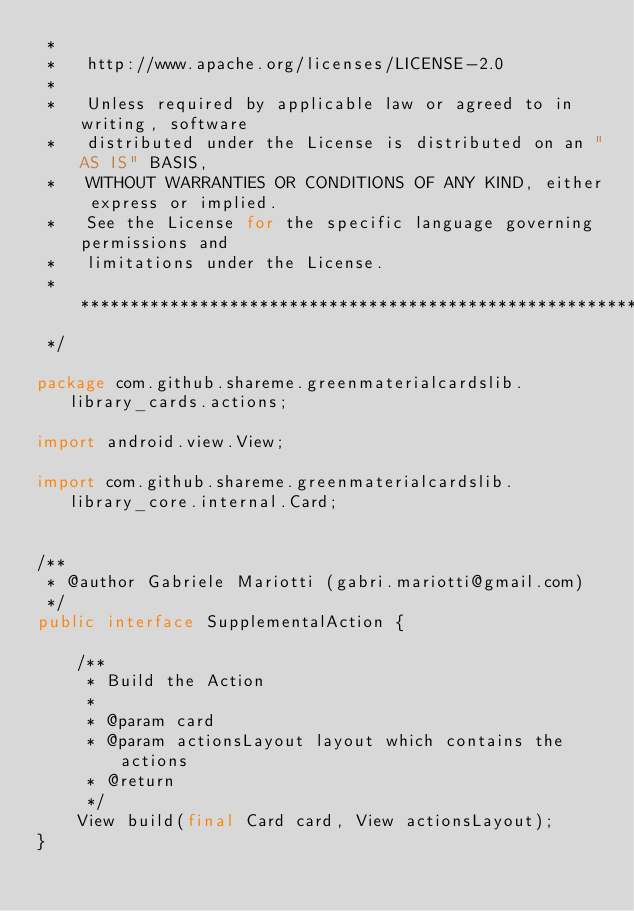Convert code to text. <code><loc_0><loc_0><loc_500><loc_500><_Java_> *
 *   http://www.apache.org/licenses/LICENSE-2.0
 *
 *   Unless required by applicable law or agreed to in writing, software
 *   distributed under the License is distributed on an "AS IS" BASIS,
 *   WITHOUT WARRANTIES OR CONDITIONS OF ANY KIND, either express or implied.
 *   See the License for the specific language governing permissions and
 *   limitations under the License.
 *  *****************************************************************************
 */

package com.github.shareme.greenmaterialcardslib.library_cards.actions;

import android.view.View;

import com.github.shareme.greenmaterialcardslib.library_core.internal.Card;


/**
 * @author Gabriele Mariotti (gabri.mariotti@gmail.com)
 */
public interface SupplementalAction {

    /**
     * Build the Action
     *
     * @param card
     * @param actionsLayout layout which contains the actions
     * @return
     */
    View build(final Card card, View actionsLayout);
}
</code> 